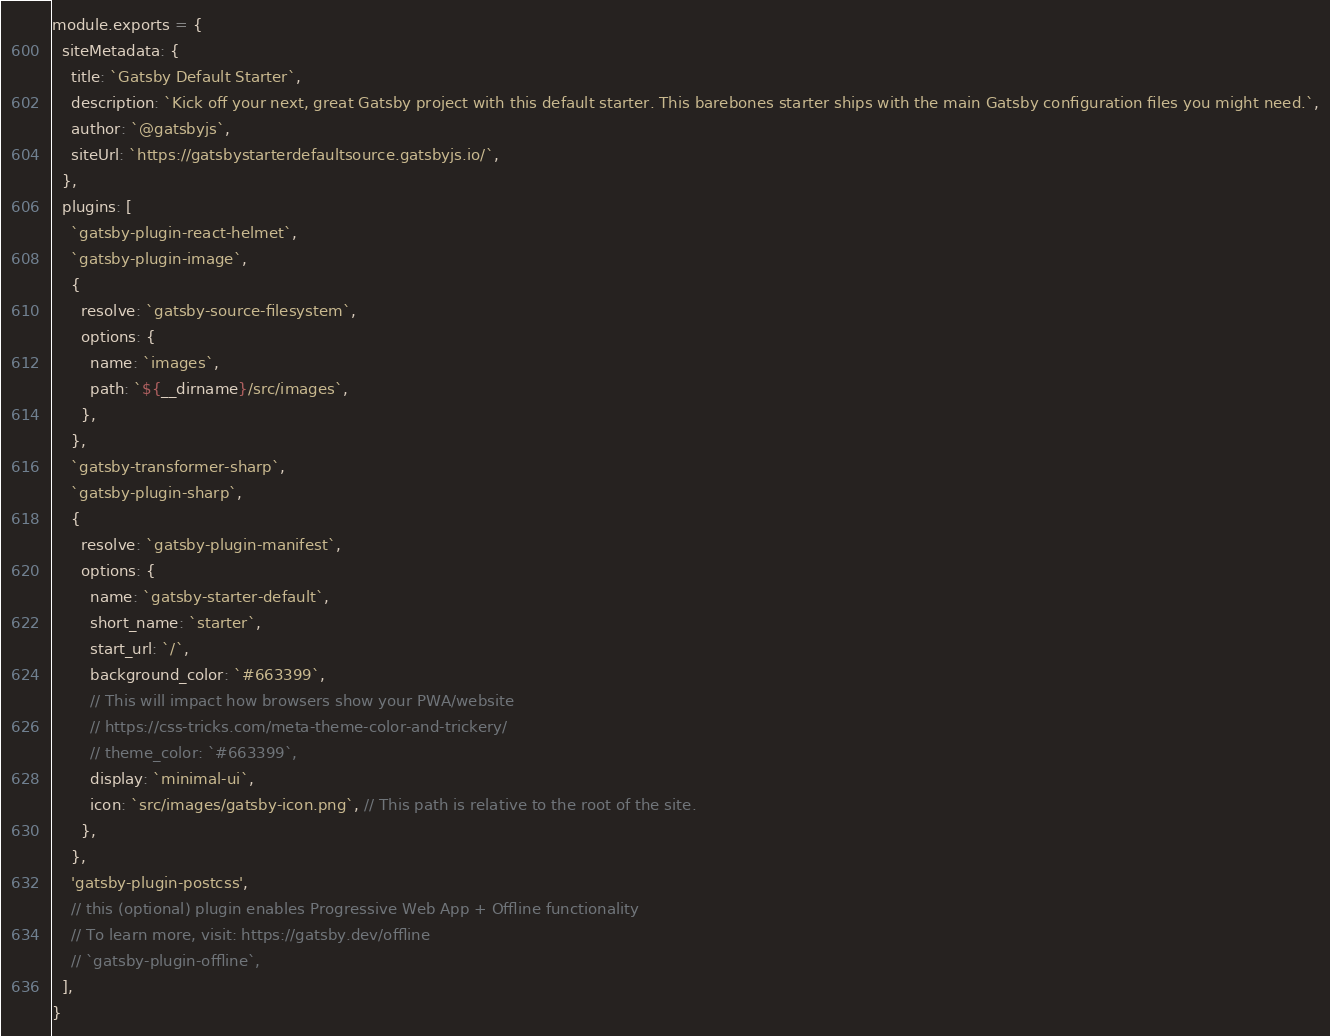Convert code to text. <code><loc_0><loc_0><loc_500><loc_500><_JavaScript_>module.exports = {
  siteMetadata: {
    title: `Gatsby Default Starter`,
    description: `Kick off your next, great Gatsby project with this default starter. This barebones starter ships with the main Gatsby configuration files you might need.`,
    author: `@gatsbyjs`,
    siteUrl: `https://gatsbystarterdefaultsource.gatsbyjs.io/`,
  },
  plugins: [
    `gatsby-plugin-react-helmet`,
    `gatsby-plugin-image`,
    {
      resolve: `gatsby-source-filesystem`,
      options: {
        name: `images`,
        path: `${__dirname}/src/images`,
      },
    },
    `gatsby-transformer-sharp`,
    `gatsby-plugin-sharp`,
    {
      resolve: `gatsby-plugin-manifest`,
      options: {
        name: `gatsby-starter-default`,
        short_name: `starter`,
        start_url: `/`,
        background_color: `#663399`,
        // This will impact how browsers show your PWA/website
        // https://css-tricks.com/meta-theme-color-and-trickery/
        // theme_color: `#663399`,
        display: `minimal-ui`,
        icon: `src/images/gatsby-icon.png`, // This path is relative to the root of the site.
      },
    },
    'gatsby-plugin-postcss',
    // this (optional) plugin enables Progressive Web App + Offline functionality
    // To learn more, visit: https://gatsby.dev/offline
    // `gatsby-plugin-offline`,
  ],
}
</code> 